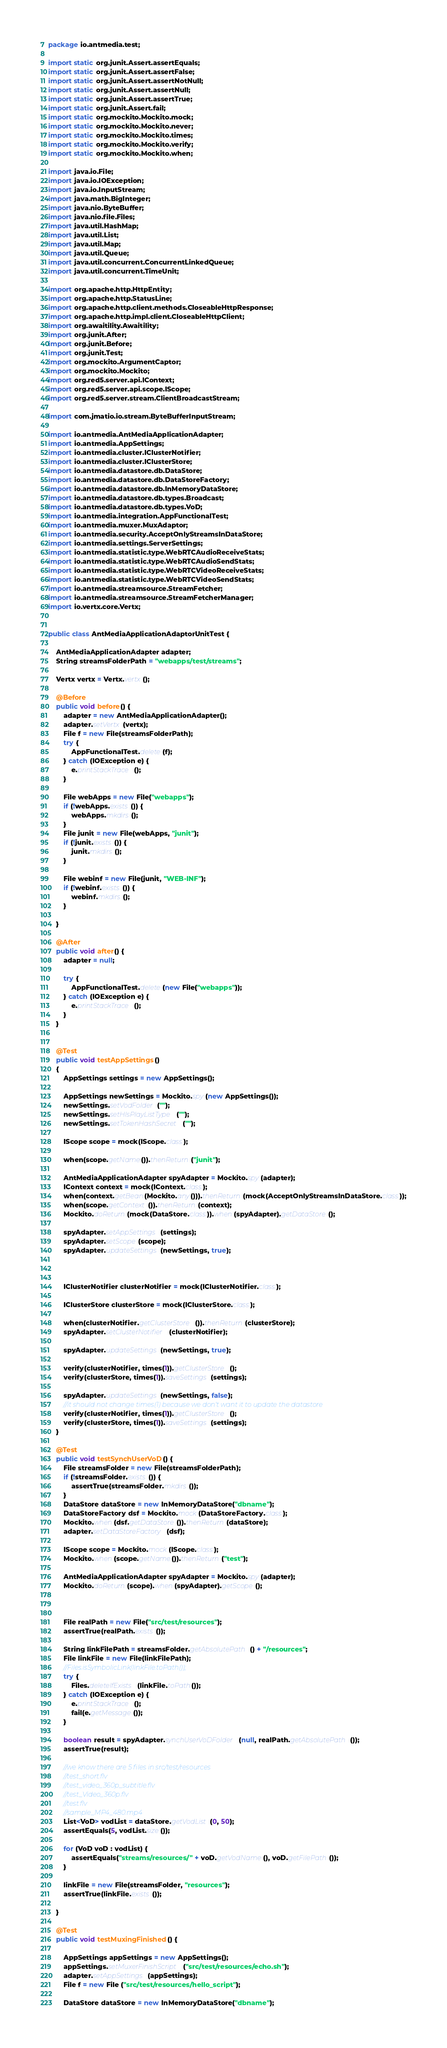Convert code to text. <code><loc_0><loc_0><loc_500><loc_500><_Java_>package io.antmedia.test;

import static org.junit.Assert.assertEquals;
import static org.junit.Assert.assertFalse;
import static org.junit.Assert.assertNotNull;
import static org.junit.Assert.assertNull;
import static org.junit.Assert.assertTrue;
import static org.junit.Assert.fail;
import static org.mockito.Mockito.mock;
import static org.mockito.Mockito.never;
import static org.mockito.Mockito.times;
import static org.mockito.Mockito.verify;
import static org.mockito.Mockito.when;

import java.io.File;
import java.io.IOException;
import java.io.InputStream;
import java.math.BigInteger;
import java.nio.ByteBuffer;
import java.nio.file.Files;
import java.util.HashMap;
import java.util.List;
import java.util.Map;
import java.util.Queue;
import java.util.concurrent.ConcurrentLinkedQueue;
import java.util.concurrent.TimeUnit;

import org.apache.http.HttpEntity;
import org.apache.http.StatusLine;
import org.apache.http.client.methods.CloseableHttpResponse;
import org.apache.http.impl.client.CloseableHttpClient;
import org.awaitility.Awaitility;
import org.junit.After;
import org.junit.Before;
import org.junit.Test;
import org.mockito.ArgumentCaptor;
import org.mockito.Mockito;
import org.red5.server.api.IContext;
import org.red5.server.api.scope.IScope;
import org.red5.server.stream.ClientBroadcastStream;

import com.jmatio.io.stream.ByteBufferInputStream;

import io.antmedia.AntMediaApplicationAdapter;
import io.antmedia.AppSettings;
import io.antmedia.cluster.IClusterNotifier;
import io.antmedia.cluster.IClusterStore;
import io.antmedia.datastore.db.DataStore;
import io.antmedia.datastore.db.DataStoreFactory;
import io.antmedia.datastore.db.InMemoryDataStore;
import io.antmedia.datastore.db.types.Broadcast;
import io.antmedia.datastore.db.types.VoD;
import io.antmedia.integration.AppFunctionalTest;
import io.antmedia.muxer.MuxAdaptor;
import io.antmedia.security.AcceptOnlyStreamsInDataStore;
import io.antmedia.settings.ServerSettings;
import io.antmedia.statistic.type.WebRTCAudioReceiveStats;
import io.antmedia.statistic.type.WebRTCAudioSendStats;
import io.antmedia.statistic.type.WebRTCVideoReceiveStats;
import io.antmedia.statistic.type.WebRTCVideoSendStats;
import io.antmedia.streamsource.StreamFetcher;
import io.antmedia.streamsource.StreamFetcherManager;
import io.vertx.core.Vertx;


public class AntMediaApplicationAdaptorUnitTest {

	AntMediaApplicationAdapter adapter;
	String streamsFolderPath = "webapps/test/streams";

	Vertx vertx = Vertx.vertx();

	@Before
	public void before() {
		adapter = new AntMediaApplicationAdapter();
		adapter.setVertx(vertx);
		File f = new File(streamsFolderPath);
		try {
			AppFunctionalTest.delete(f);
		} catch (IOException e) {
			e.printStackTrace();
		}

		File webApps = new File("webapps");
		if (!webApps.exists()) {
			webApps.mkdirs();
		}
		File junit = new File(webApps, "junit");
		if (!junit.exists()) {
			junit.mkdirs();
		}
		
		File webinf = new File(junit, "WEB-INF");
		if (!webinf.exists()) {
			webinf.mkdirs();
		}

	}

	@After
	public void after() {
		adapter = null;

		try {
			AppFunctionalTest.delete(new File("webapps"));
		} catch (IOException e) {
			e.printStackTrace();
		}
	}


	@Test
	public void testAppSettings() 
	{
		AppSettings settings = new AppSettings();

		AppSettings newSettings = Mockito.spy(new AppSettings());
		newSettings.setVodFolder("");
		newSettings.setHlsPlayListType("");
		newSettings.setTokenHashSecret("");

		IScope scope = mock(IScope.class);

		when(scope.getName()).thenReturn("junit");

		AntMediaApplicationAdapter spyAdapter = Mockito.spy(adapter);
		IContext context = mock(IContext.class);
		when(context.getBean(Mockito.any())).thenReturn(mock(AcceptOnlyStreamsInDataStore.class));
		when(scope.getContext()).thenReturn(context);
		Mockito.doReturn(mock(DataStore.class)).when(spyAdapter).getDataStore();
		
		spyAdapter.setAppSettings(settings);
		spyAdapter.setScope(scope);
		spyAdapter.updateSettings(newSettings, true);
		
		

		IClusterNotifier clusterNotifier = mock(IClusterNotifier.class);

		IClusterStore clusterStore = mock(IClusterStore.class);

		when(clusterNotifier.getClusterStore()).thenReturn(clusterStore);
		spyAdapter.setClusterNotifier(clusterNotifier);

		spyAdapter.updateSettings(newSettings, true);

		verify(clusterNotifier, times(1)).getClusterStore();
		verify(clusterStore, times(1)).saveSettings(settings);
		
		spyAdapter.updateSettings(newSettings, false);
		//it should not change times(1) because we don't want it to update the datastore
		verify(clusterNotifier, times(1)).getClusterStore();
		verify(clusterStore, times(1)).saveSettings(settings);
	}

	@Test
	public void testSynchUserVoD() {
		File streamsFolder = new File(streamsFolderPath);
		if (!streamsFolder.exists()) {
			assertTrue(streamsFolder.mkdirs());
		}
		DataStore dataStore = new InMemoryDataStore("dbname");
		DataStoreFactory dsf = Mockito.mock(DataStoreFactory.class);
		Mockito.when(dsf.getDataStore()).thenReturn(dataStore);
		adapter.setDataStoreFactory(dsf);

		IScope scope = Mockito.mock(IScope.class);
		Mockito.when(scope.getName()).thenReturn("test");

		AntMediaApplicationAdapter spyAdapter = Mockito.spy(adapter);
		Mockito.doReturn(scope).when(spyAdapter).getScope();



		File realPath = new File("src/test/resources");
		assertTrue(realPath.exists());

		String linkFilePath = streamsFolder.getAbsolutePath() + "/resources";
		File linkFile = new File(linkFilePath);
		//Files.isSymbolicLink(linkFile.toPath());
		try {
			Files.deleteIfExists(linkFile.toPath());
		} catch (IOException e) {
			e.printStackTrace();
			fail(e.getMessage());
		}

		boolean result = spyAdapter.synchUserVoDFolder(null, realPath.getAbsolutePath());
		assertTrue(result);

		//we know there are 5 files in src/test/resources
		//test_short.flv
		//test_video_360p_subtitle.flv
		//test_Video_360p.flv
		//test.flv
		//sample_MP4_480.mp4
		List<VoD> vodList = dataStore.getVodList(0, 50);
		assertEquals(5, vodList.size());

		for (VoD voD : vodList) {
			assertEquals("streams/resources/" + voD.getVodName(), voD.getFilePath());
		}

		linkFile = new File(streamsFolder, "resources");
		assertTrue(linkFile.exists());

	}

	@Test
	public void testMuxingFinished() {

		AppSettings appSettings = new AppSettings();
		appSettings.setMuxerFinishScript("src/test/resources/echo.sh");
		adapter.setAppSettings(appSettings);
		File f = new File ("src/test/resources/hello_script");

		DataStore dataStore = new InMemoryDataStore("dbname");</code> 